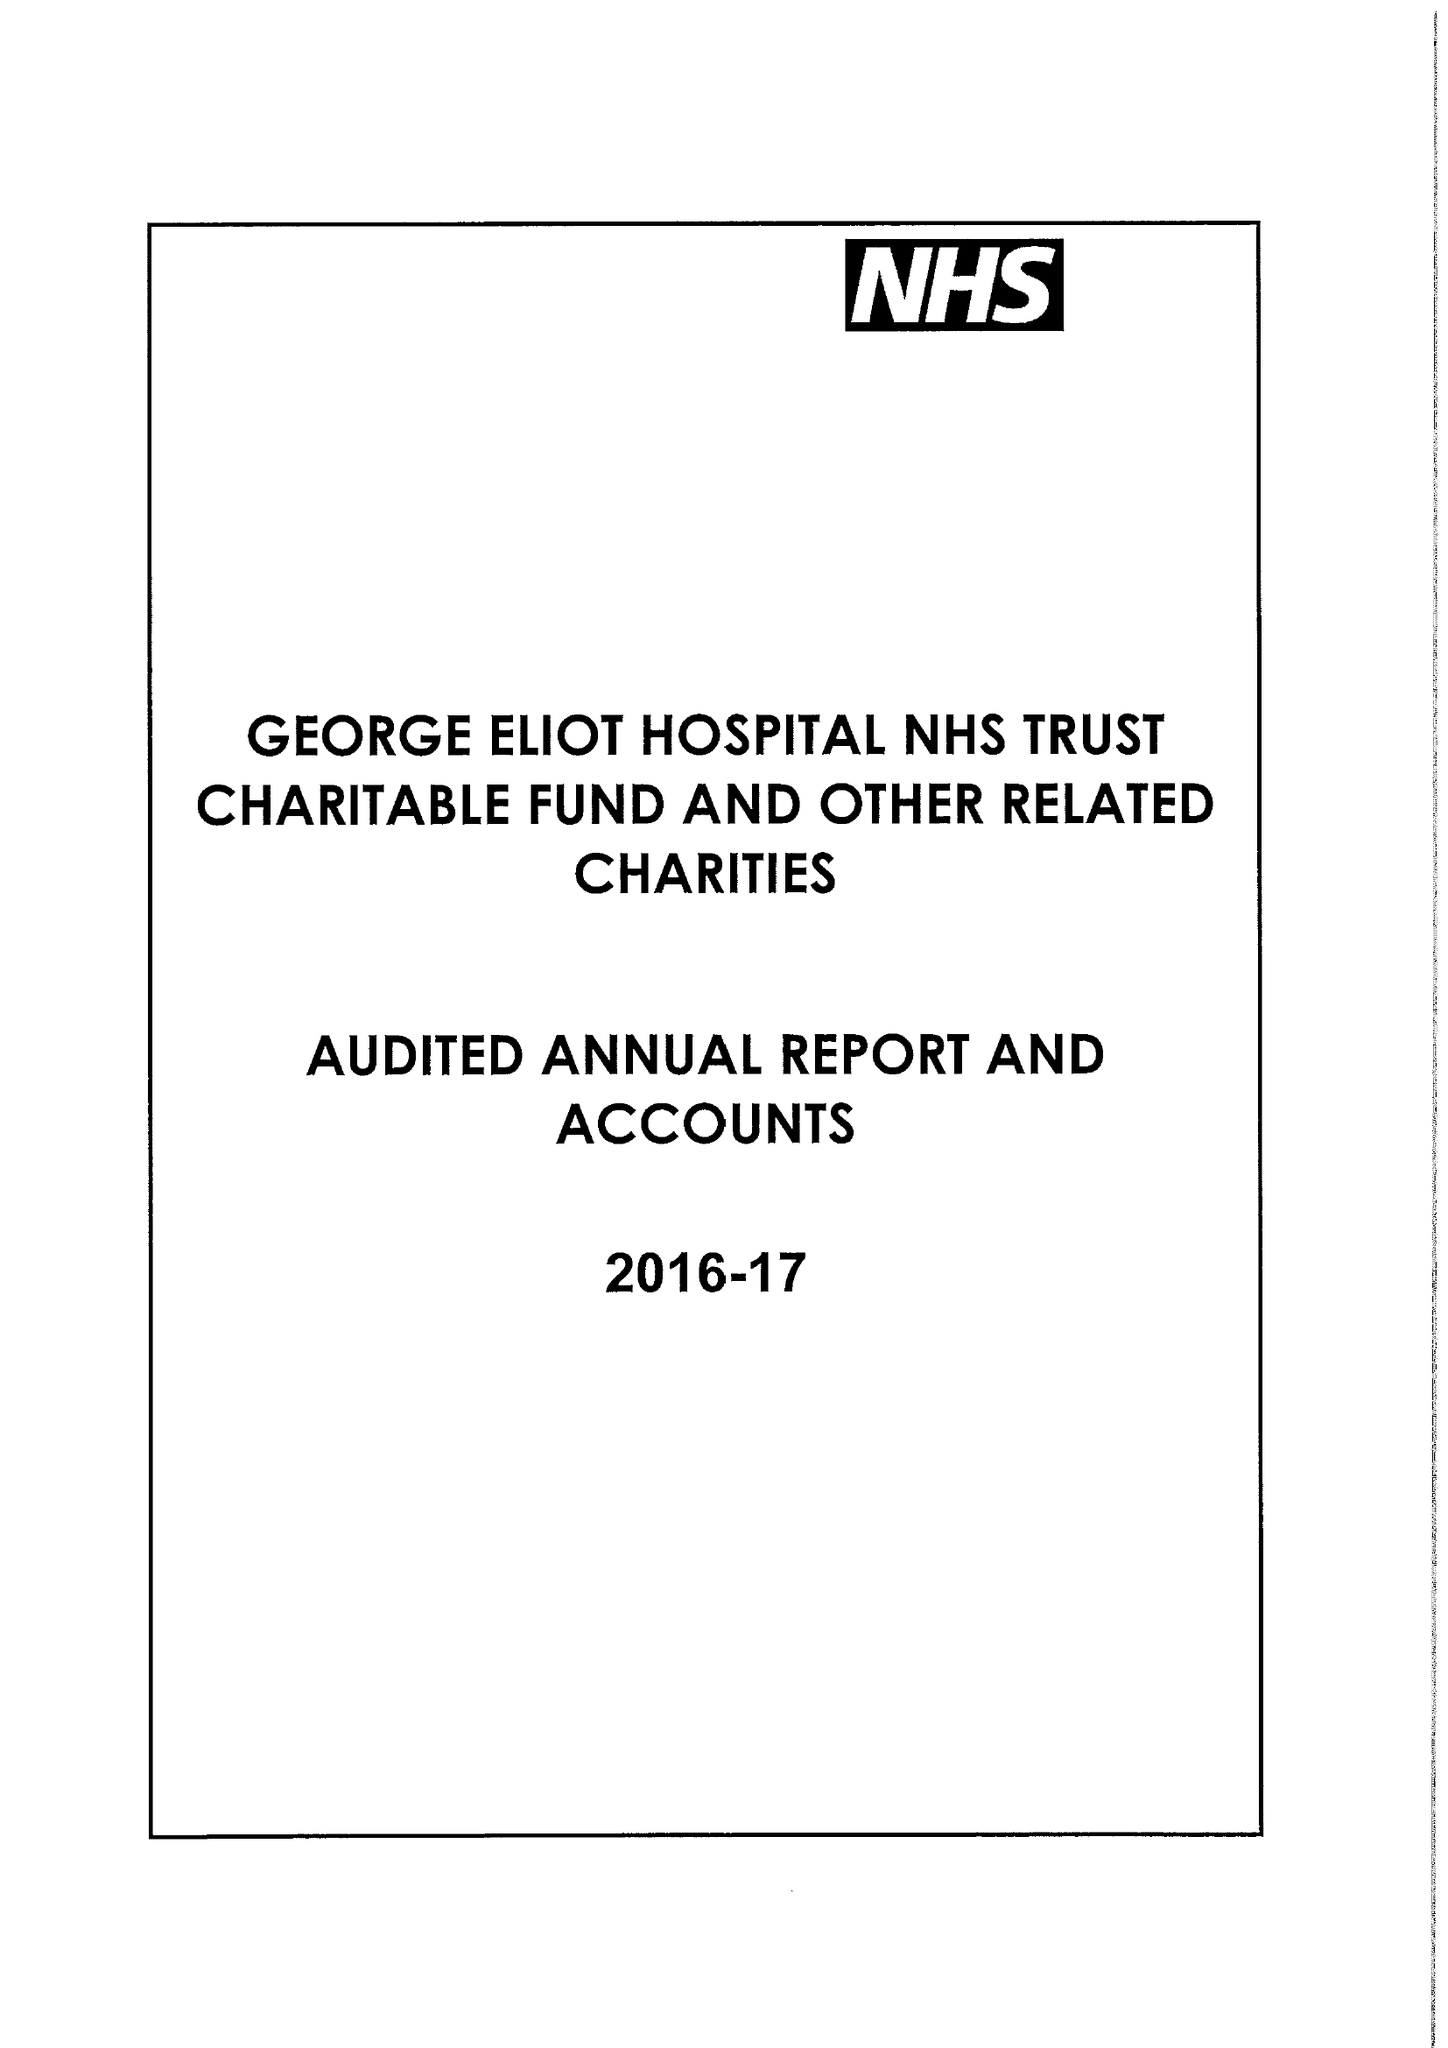What is the value for the address__postcode?
Answer the question using a single word or phrase. CV10 7DJ 